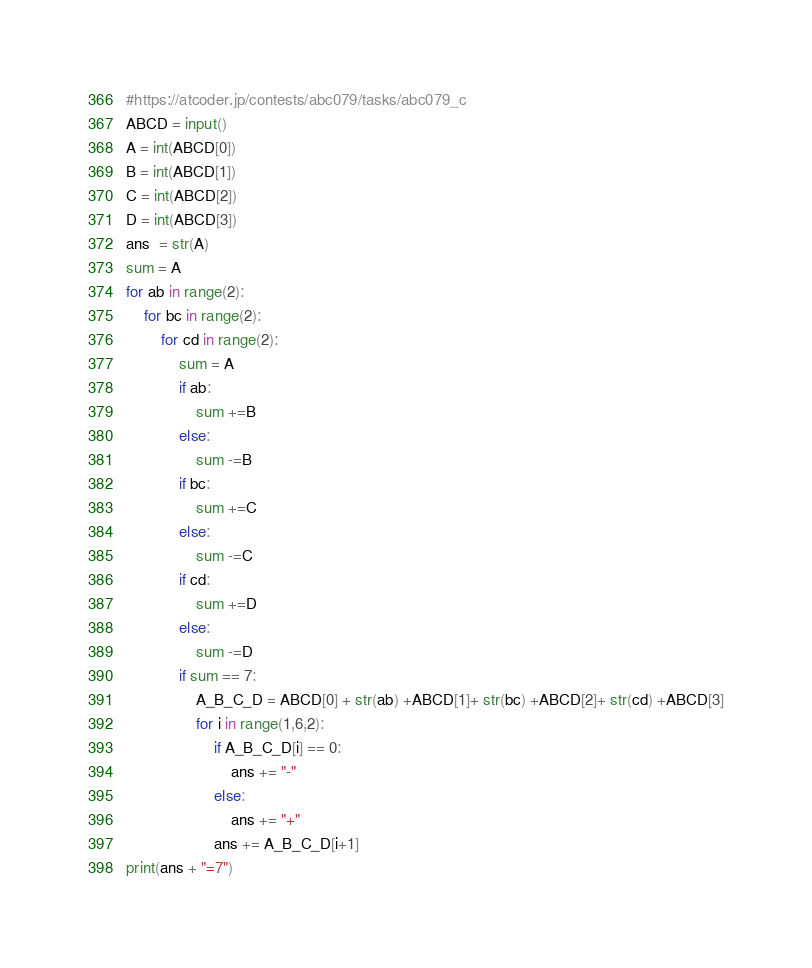Convert code to text. <code><loc_0><loc_0><loc_500><loc_500><_Python_>#https://atcoder.jp/contests/abc079/tasks/abc079_c
ABCD = input()
A = int(ABCD[0])
B = int(ABCD[1])
C = int(ABCD[2])
D = int(ABCD[3])
ans  = str(A)
sum = A
for ab in range(2):
    for bc in range(2):
        for cd in range(2):
            sum = A
            if ab:
                sum +=B
            else:
                sum -=B
            if bc:
                sum +=C
            else:
                sum -=C
            if cd:
                sum +=D
            else:
                sum -=D
            if sum == 7:
                A_B_C_D = ABCD[0] + str(ab) +ABCD[1]+ str(bc) +ABCD[2]+ str(cd) +ABCD[3]
                for i in range(1,6,2):
                    if A_B_C_D[i] == 0:
                        ans += "-"
                    else:
                        ans += "+"
                    ans += A_B_C_D[i+1]
print(ans + "=7")</code> 